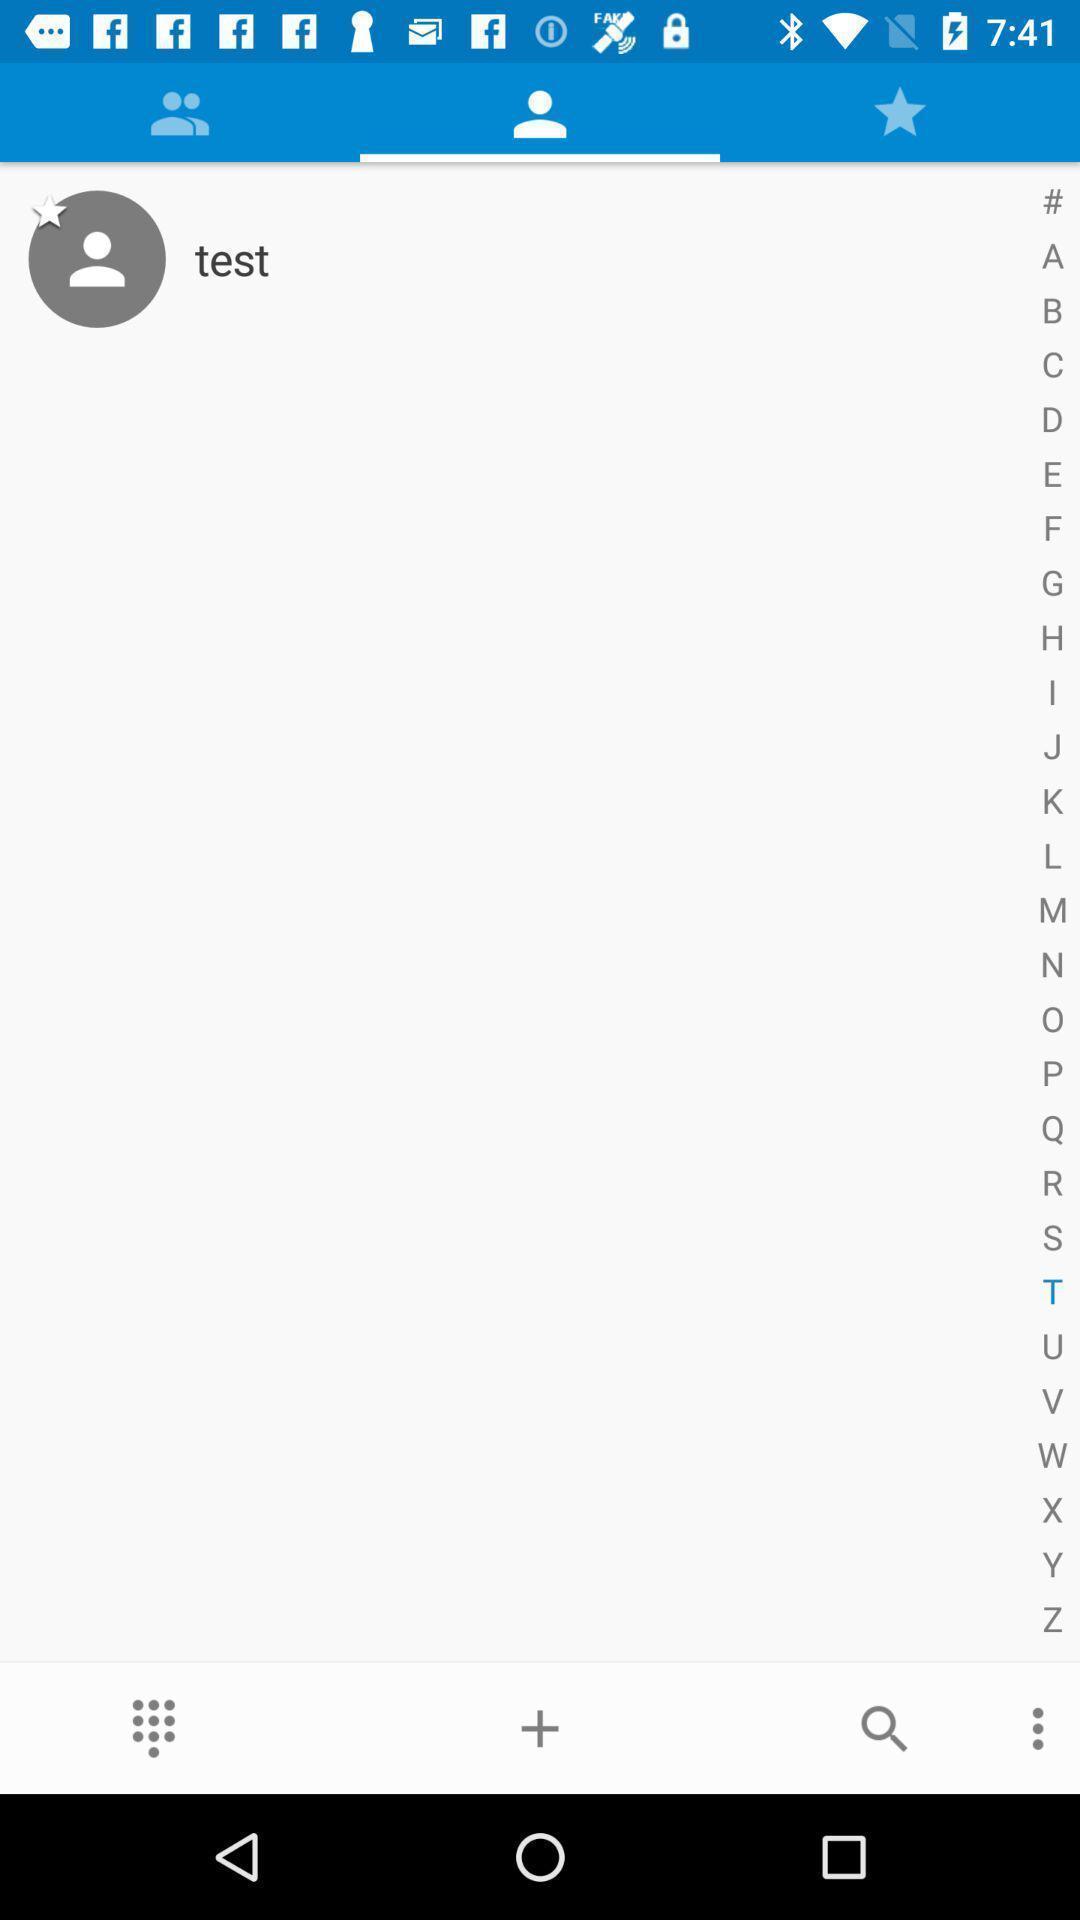Describe the key features of this screenshot. Page displaying with test contact and few options. 